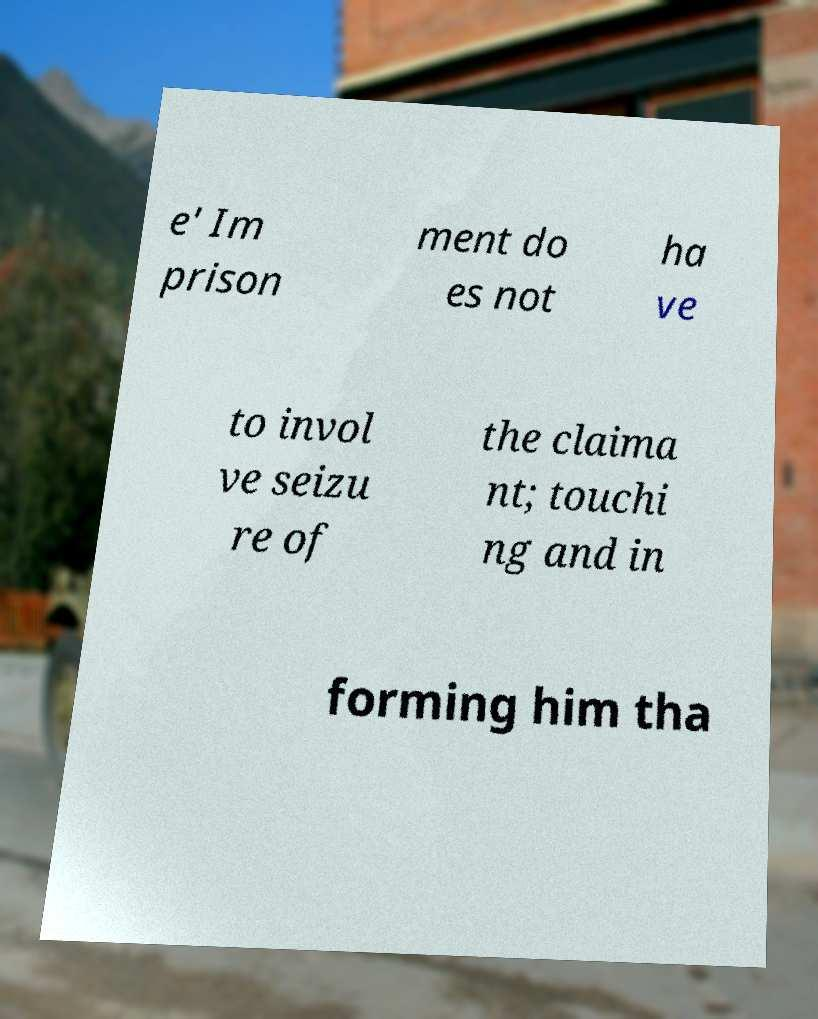Could you extract and type out the text from this image? e' Im prison ment do es not ha ve to invol ve seizu re of the claima nt; touchi ng and in forming him tha 